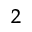Convert formula to latex. <formula><loc_0><loc_0><loc_500><loc_500>_ { 2 }</formula> 